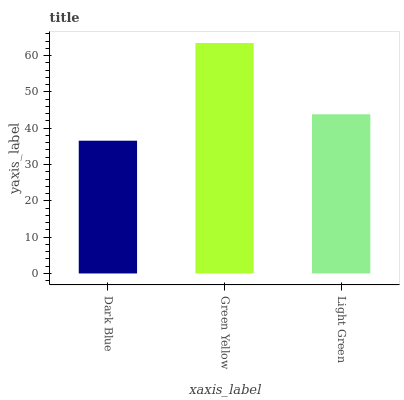Is Dark Blue the minimum?
Answer yes or no. Yes. Is Green Yellow the maximum?
Answer yes or no. Yes. Is Light Green the minimum?
Answer yes or no. No. Is Light Green the maximum?
Answer yes or no. No. Is Green Yellow greater than Light Green?
Answer yes or no. Yes. Is Light Green less than Green Yellow?
Answer yes or no. Yes. Is Light Green greater than Green Yellow?
Answer yes or no. No. Is Green Yellow less than Light Green?
Answer yes or no. No. Is Light Green the high median?
Answer yes or no. Yes. Is Light Green the low median?
Answer yes or no. Yes. Is Dark Blue the high median?
Answer yes or no. No. Is Green Yellow the low median?
Answer yes or no. No. 